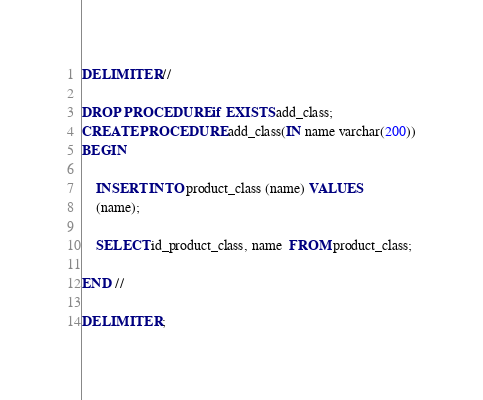Convert code to text. <code><loc_0><loc_0><loc_500><loc_500><_SQL_>DELIMITER //

DROP PROCEDURE if EXISTS add_class;
CREATE PROCEDURE add_class(IN name varchar(200))
BEGIN

    INSERT INTO product_class (name) VALUES
    (name);

    SELECT id_product_class, name  FROM product_class;

END //

DELIMITER ;
</code> 